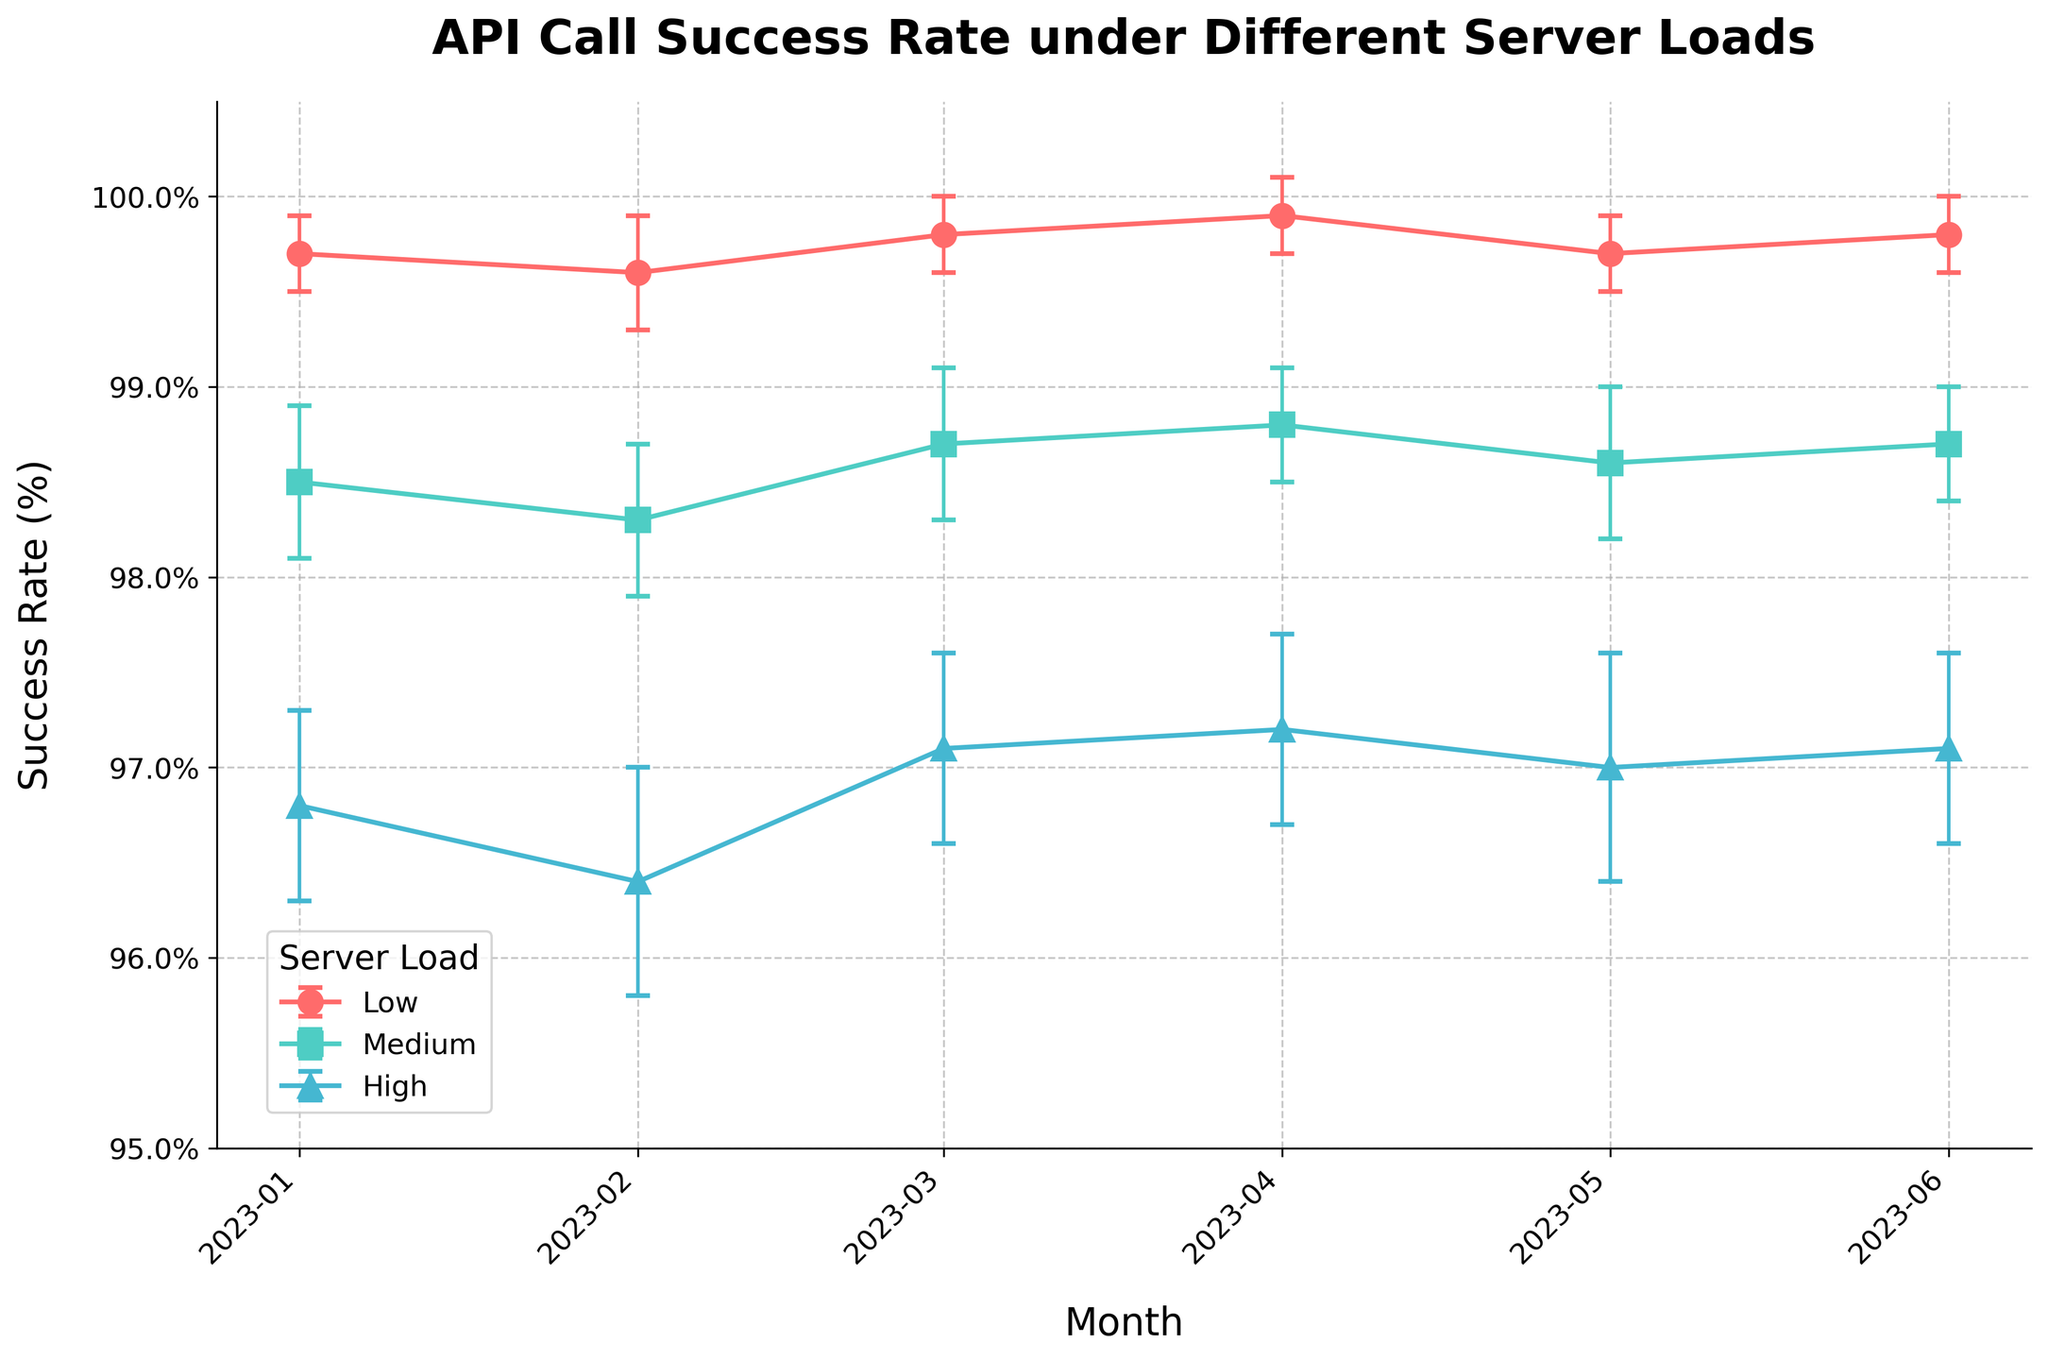What is the title of the plot? The title of the plot is found at the top, often in a larger and bolder font compared to the rest of the text in the figure.
Answer: API Call Success Rate under Different Server Loads How many server load categories are there? The number of server load categories can be identified by the distinct colors and labels in the legend.
Answer: Three What months are displayed on the x-axis? The months can be seen on the x-axis, usually formatted at regular intervals.
Answer: January 2023 to June 2023 What is the highest success rate for high server load and when did it occur? The highest point on the line representing high server load can be observed, along with its corresponding month on the x-axis.
Answer: 97.2% in April 2023 During which month did medium server load experience the lowest success rate and what was it? The lowest point on the line representing medium server load can be identified along with the corresponding month on the x-axis.
Answer: February 2023, 98.3% What's the average success rate for low server load across the six months? Sum all the success rates for low server load and divide by the number of months (6). (99.7 + 99.6 + 99.8 + 99.9 + 99.7 + 99.8) / 6 = 99.75
Answer: 99.75% Compare the success rate trends between low and high server load. Which one shows more stability? Observing the overall line trends and error bars for low and high server loads can help determine which line has fewer fluctuations.
Answer: Low server load shows more stability What is the error margin for medium server load in March, and how does it compare to the error margin for high server load in the same month? Examine the error bars for medium and high server loads in March. Medium has an error margin of 0.4, and high has an error margin of 0.5.
Answer: Medium: 0.4, High: 0.5 How does the success rate in June for low server load compare to medium server load? Compare the points on the graph for June for both low and medium server loads. Low has a success rate of 99.8%, and Medium has 98.7%.
Answer: Low is higher, 99.8% vs. 98.7% 